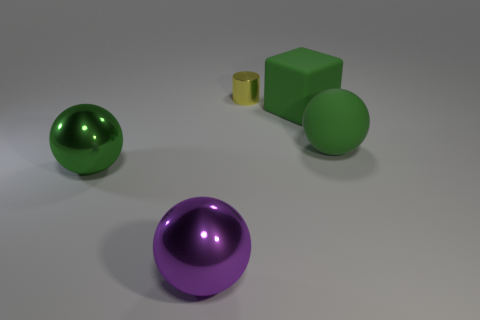Is there anything else that has the same size as the yellow shiny cylinder?
Your answer should be compact. No. What size is the purple sphere?
Keep it short and to the point. Large. Are there any large metallic spheres that have the same color as the matte cube?
Provide a succinct answer. Yes. There is a metallic thing that is right of the green metal object and in front of the big green block; what is its size?
Your response must be concise. Large. What is the material of the big cube that is the same color as the matte sphere?
Keep it short and to the point. Rubber. How many spheres are cyan rubber things or matte things?
Your answer should be compact. 1. The metallic object that is the same color as the cube is what size?
Ensure brevity in your answer.  Large. Are there fewer large shiny things behind the tiny yellow cylinder than tiny blue rubber cylinders?
Offer a very short reply. No. The big sphere that is behind the big purple ball and to the left of the large green rubber cube is what color?
Offer a very short reply. Green. How many other objects are there of the same shape as the big purple shiny object?
Your response must be concise. 2. 